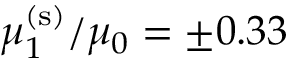<formula> <loc_0><loc_0><loc_500><loc_500>\mu _ { 1 } ^ { ( s ) } / \mu _ { 0 } = \pm 0 . 3 3</formula> 